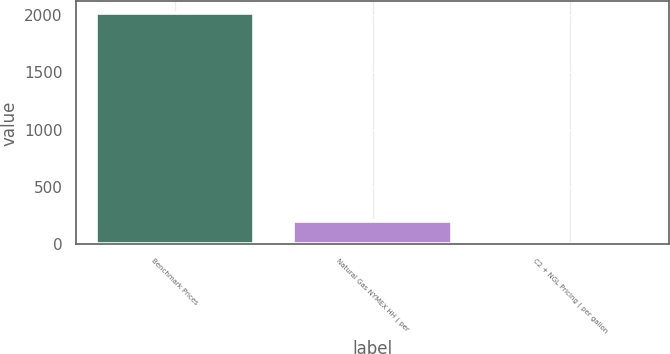<chart> <loc_0><loc_0><loc_500><loc_500><bar_chart><fcel>Benchmark Prices<fcel>Natural Gas NYMEX HH ( per<fcel>C2 + NGL Pricing ( per gallon<nl><fcel>2018<fcel>202.5<fcel>0.78<nl></chart> 